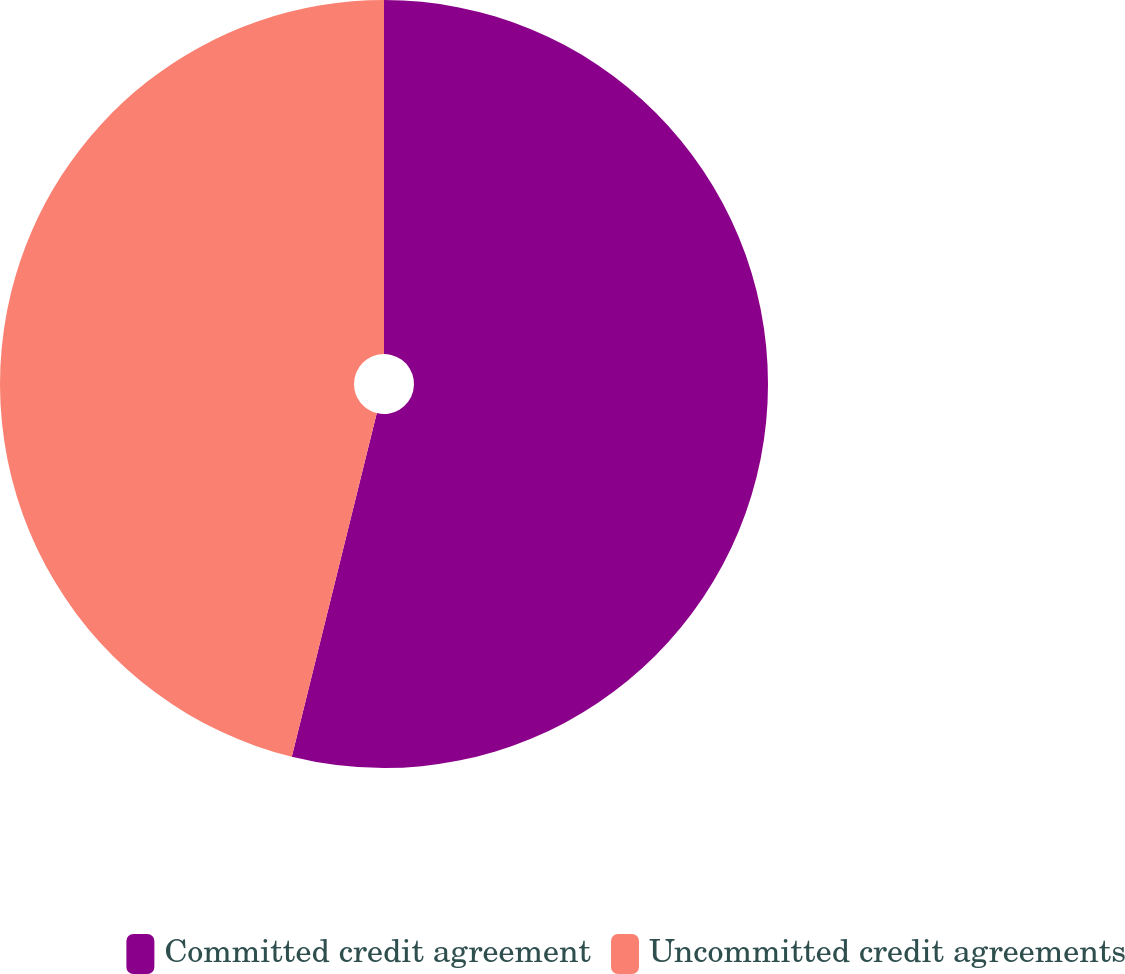Convert chart to OTSL. <chart><loc_0><loc_0><loc_500><loc_500><pie_chart><fcel>Committed credit agreement<fcel>Uncommitted credit agreements<nl><fcel>53.86%<fcel>46.14%<nl></chart> 